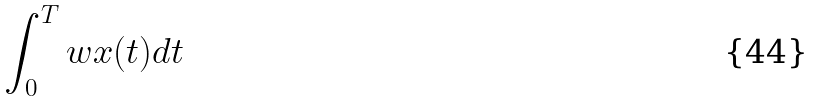<formula> <loc_0><loc_0><loc_500><loc_500>\int _ { 0 } ^ { T } w x ( t ) d t</formula> 